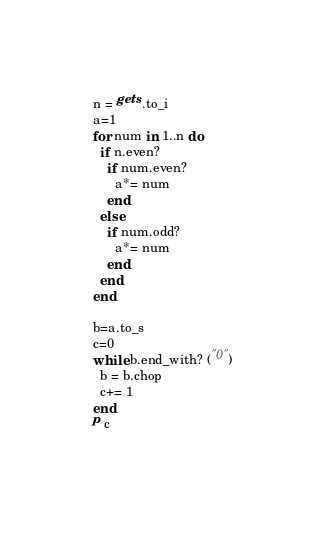<code> <loc_0><loc_0><loc_500><loc_500><_Ruby_>n = gets.to_i
a=1
for num in 1..n do
  if n.even?
    if num.even?
      a*= num
    end
  else
    if num.odd?
      a*= num
    end
  end  
end  

b=a.to_s
c=0  
while b.end_with? ("0")
  b = b.chop
  c+= 1
end
p c
  </code> 